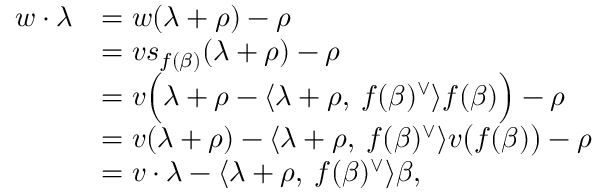Convert formula to latex. <formula><loc_0><loc_0><loc_500><loc_500>\begin{array} { r l } { w \cdot \lambda } & { = w ( \lambda + \rho ) - \rho } \\ & { = v s _ { f ( \beta ) } ( \lambda + \rho ) - \rho } \\ & { = v \left ( \lambda + \rho - \langle \lambda + \rho , \, f ( \beta ) ^ { \vee } \rangle f ( \beta ) \right ) - \rho } \\ & { = v ( \lambda + \rho ) - \langle \lambda + \rho , \, f ( \beta ) ^ { \vee } \rangle v \left ( f ( \beta ) \right ) - \rho } \\ & { = v \cdot \lambda - \langle \lambda + \rho , \, f ( \beta ) ^ { \vee } \rangle \beta , } \end{array}</formula> 